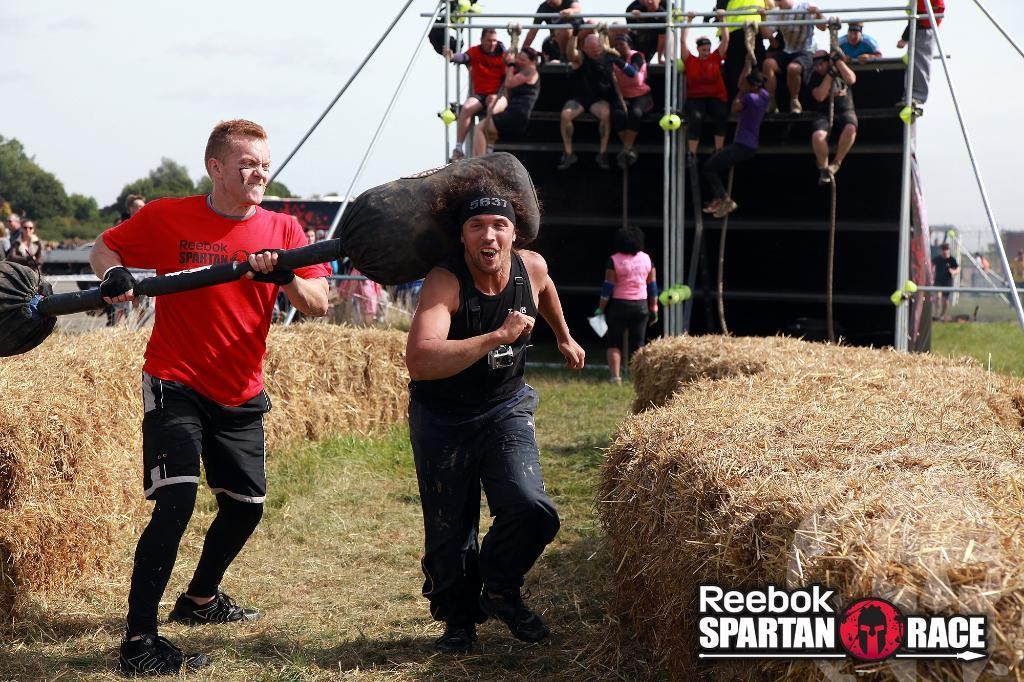What is the person in the foreground of the image wearing? The person in the foreground is wearing a black dress. What is the person in the black dress doing? The person wearing a black dress is running. What is the person in the red dress holding? The person wearing a red dress is holding an object. Can you describe the people in the background of the image? There are other people in the background of the image. What type of toad can be seen jumping in the image? There is no toad present in the image. Is the person in the red dress using a gun to hold the object? There is no gun visible in the image, and the person in the red dress is not using a gun to hold the object. 